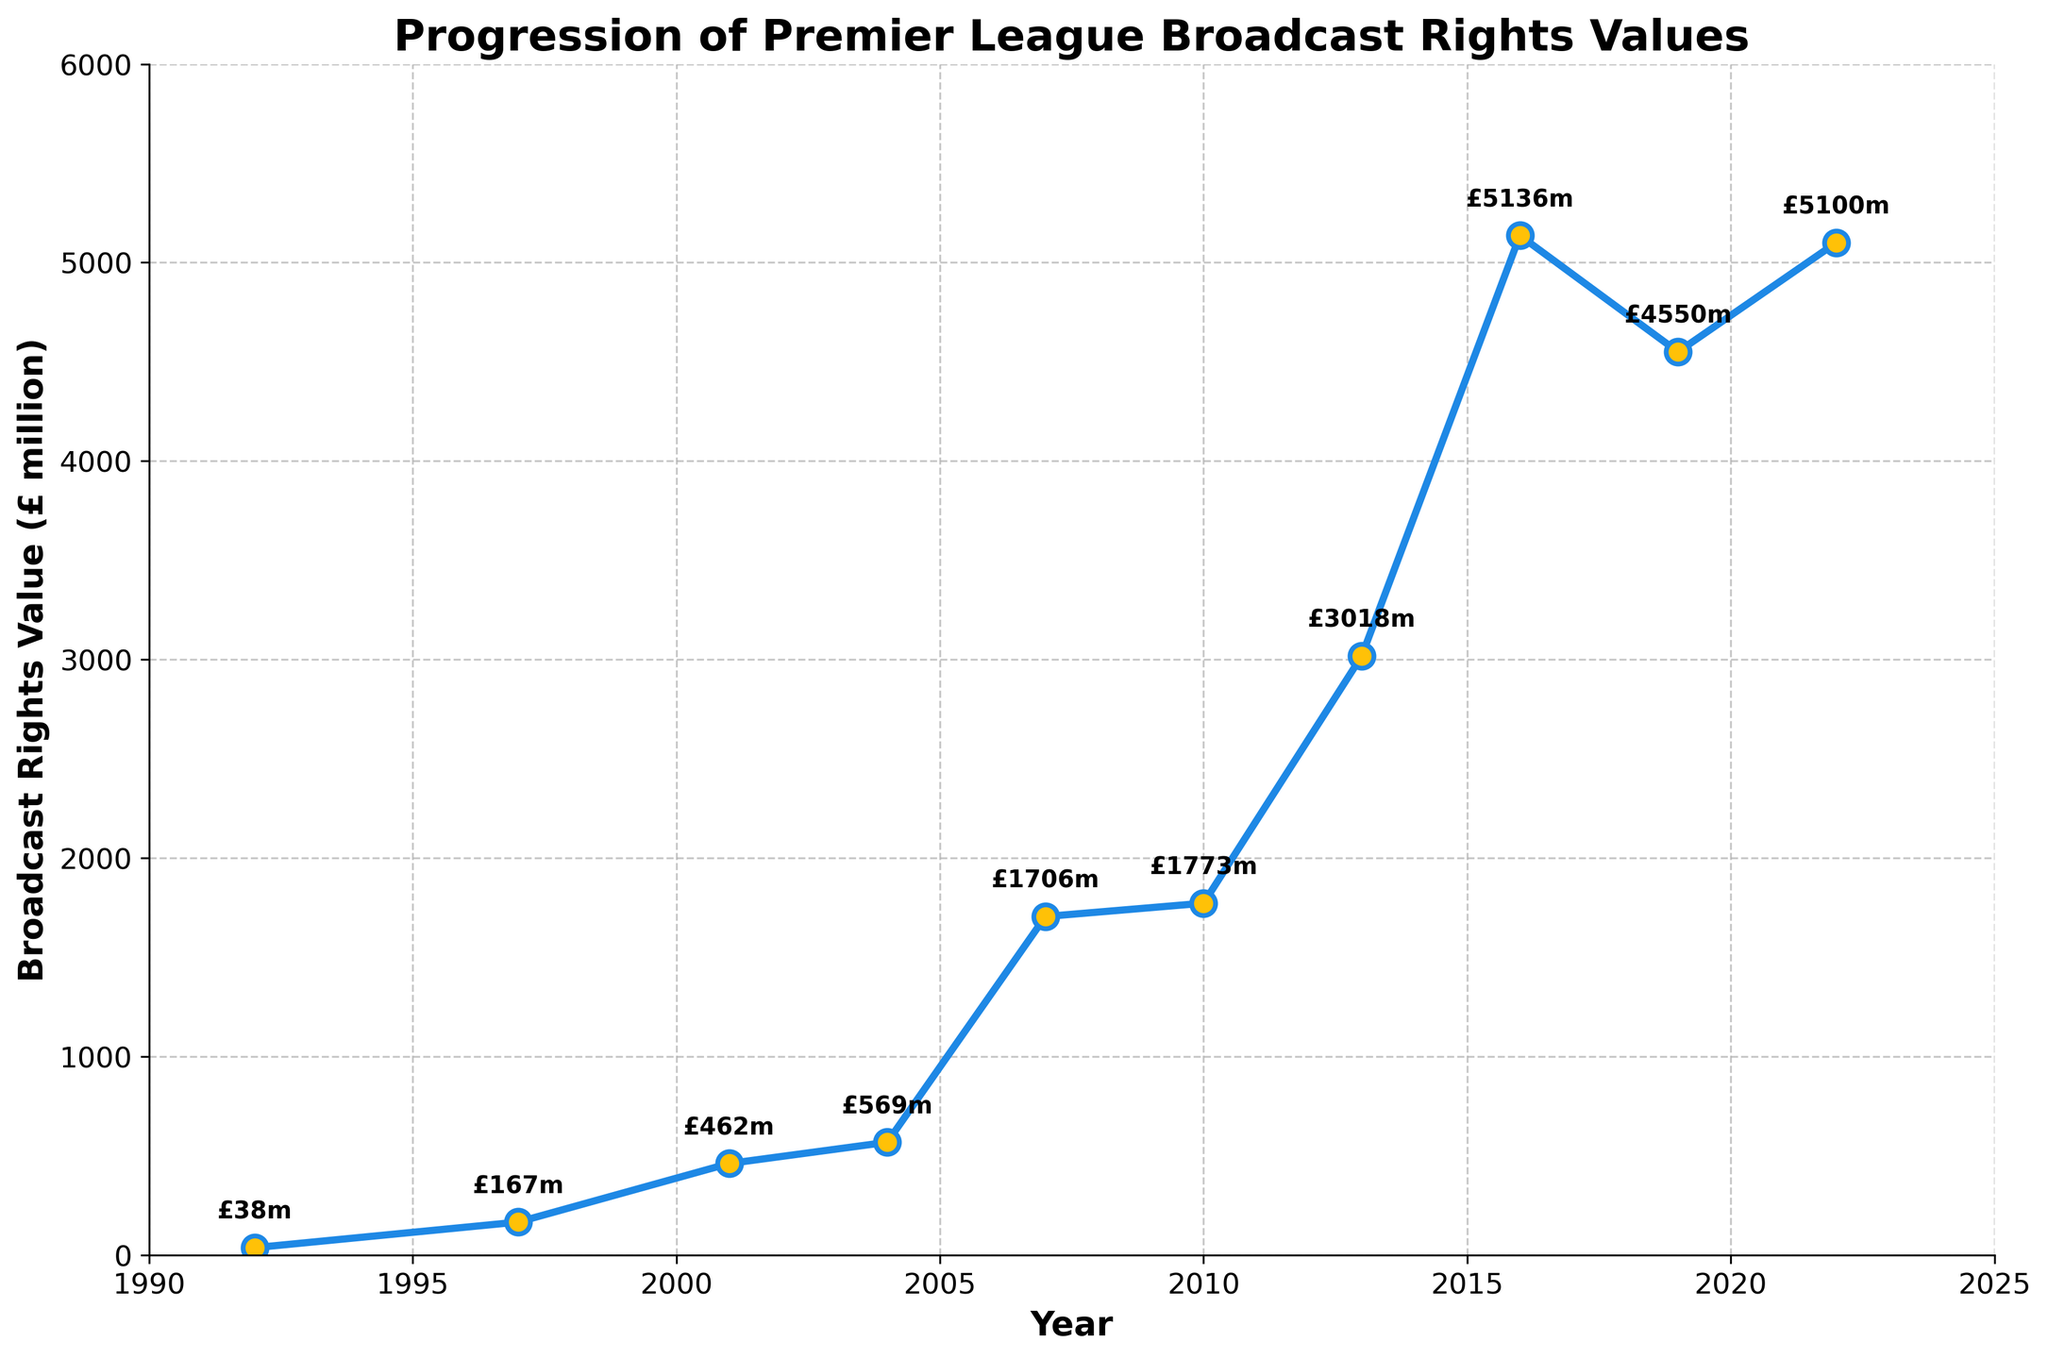What is the value of the Premier League broadcast rights in 1997? We can directly observe the value for 1997 on the graph, which is labeled as £167 million.
Answer: £167 million Which year saw the Premier League broadcast rights value exceed £3000 million for the first time? Look for the first point on the graph above £3000 million, which is labelled in 2013 when it reaches £3018 million.
Answer: 2013 How much did the broadcast rights value increase between 2001 and 2004? Subtract the value for 2001 from the value for 2004 to find the difference: £569 million - £462 million = £107 million.
Answer: £107 million How many years did it take for the Premier League broadcast rights value to increase from £38 million to over £5000 million? The value was £38 million in 1992 and it surpassed £5000 million in 2016. Calculate the time difference: 2016 - 1992 = 24 years.
Answer: 24 years Between which two consecutive periods did the Premier League broadcast rights value experience the largest increase, and what was that increase? Identify the largest difference between consecutive points: The jump from 2004 (£569 million) to 2007 (£1706 million) is the largest with an increase of £1706 million - £569 million = £1137 million.
Answer: 2004 to 2007, £1137 million By how much did the Premier League broadcast rights value decrease between 2016 and 2019? Subtract the value for 2019 from the value for 2016 to find the difference: £5136 million - £4550 million = £586 million.
Answer: £586 million Compare the broadcast rights value in 2007 to the value in 1992. How many times larger is it? Divide the 2007 value by the 1992 value: £1706 million / £38 million ≈ 44.89.
Answer: 44.89 times What is the average broadcast rights value over the period 1992 to 2022? Sum all the values and divide by the number of data points. (38 + 167 + 462 + 569 + 1706 + 1773 + 3018 + 5136 + 4550 + 5100) / 10 ≈ £2281.9 million.
Answer: £2281.9 million When did the broadcast rights value surpass £1000 million? Identify the first point on the graph above £1000 million, which is in the year 2007.
Answer: 2007 